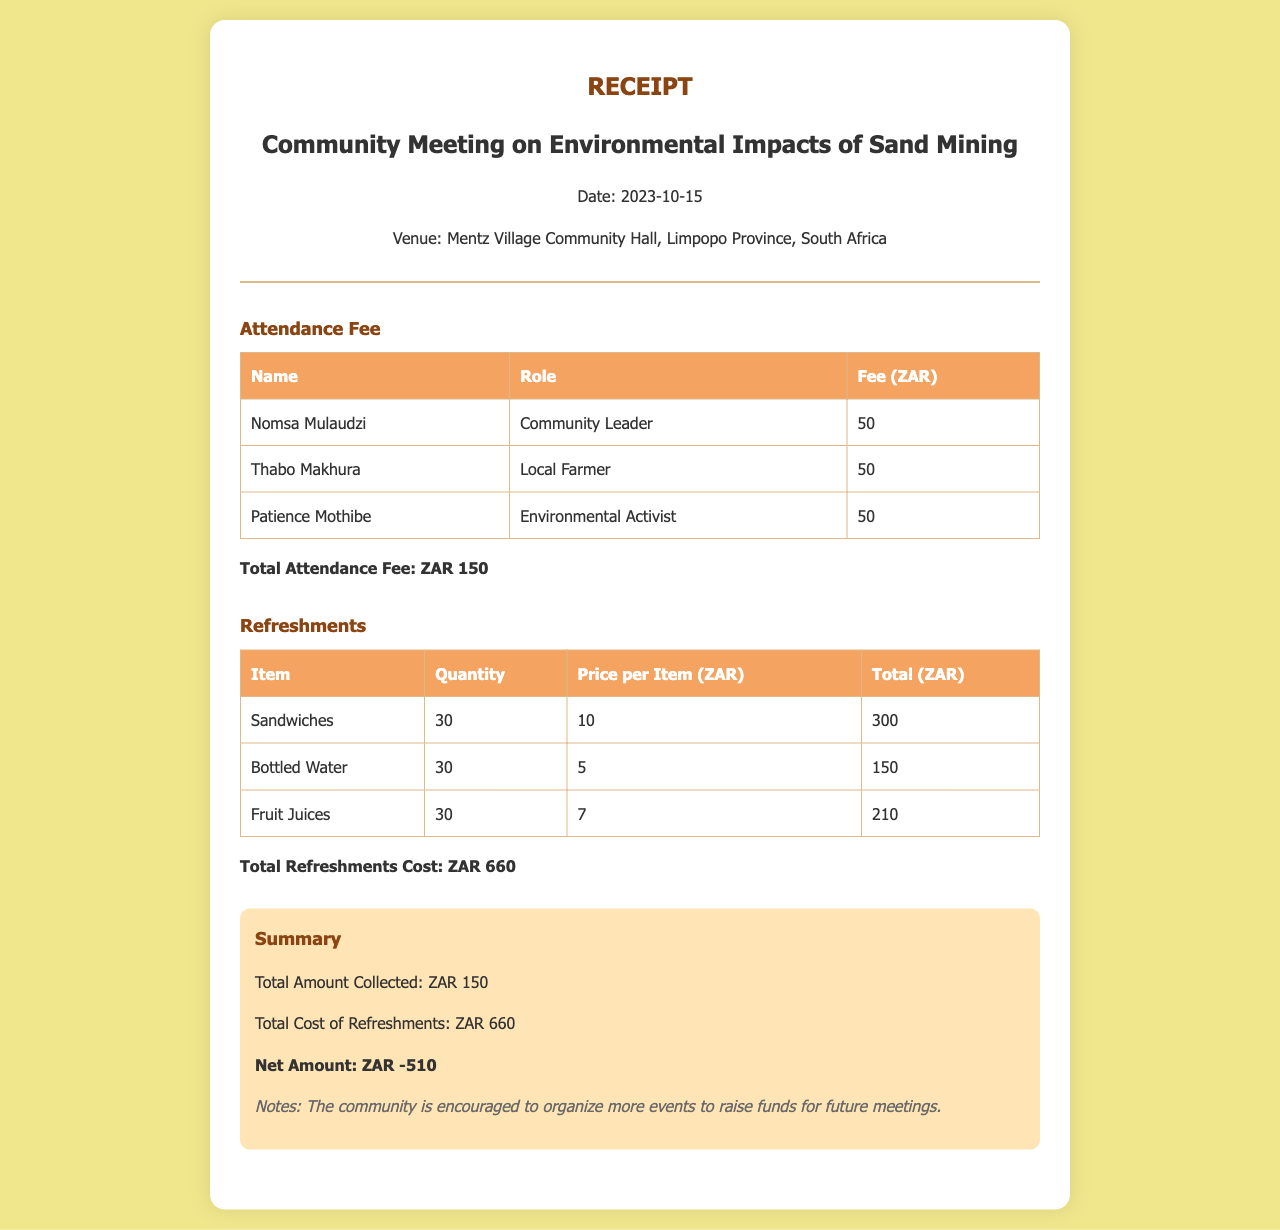What is the date of the meeting? The date of the meeting is stated in the document under the venue details.
Answer: 2023-10-15 Where was the meeting held? The meeting venue is specified in the document header.
Answer: Mentz Village Community Hall Who is the Environmental Activist mentioned? The document lists the names and roles of attendees, including their respective roles.
Answer: Patience Mothibe What is the total attendance fee collected? The document summarizes the total attendance fees at the end of the attendance section.
Answer: ZAR 150 How many sandwiches were ordered for refreshments? The quantity of sandwiches is detailed in the refreshments section of the document.
Answer: 30 What is the total cost of refreshments? The total cost of all refreshments is provided in the summary section of the document.
Answer: ZAR 660 What is the net amount calculated? The net amount is a calculation derived from the total attendance fee and total refreshments cost provided in the summary.
Answer: ZAR -510 How many people attended the meeting? The document details one attendance fee per attendee in the attendance section.
Answer: 3 What are the notes mentioned in the document? The notes section provides insight into the community's financial considerations for future events based on the summary.
Answer: The community is encouraged to organize more events to raise funds for future meetings 